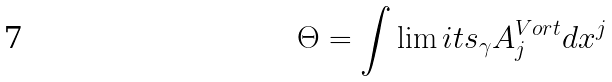<formula> <loc_0><loc_0><loc_500><loc_500>\Theta = \int \lim i t s _ { \gamma } A _ { j } ^ { V o r t } d x ^ { j }</formula> 